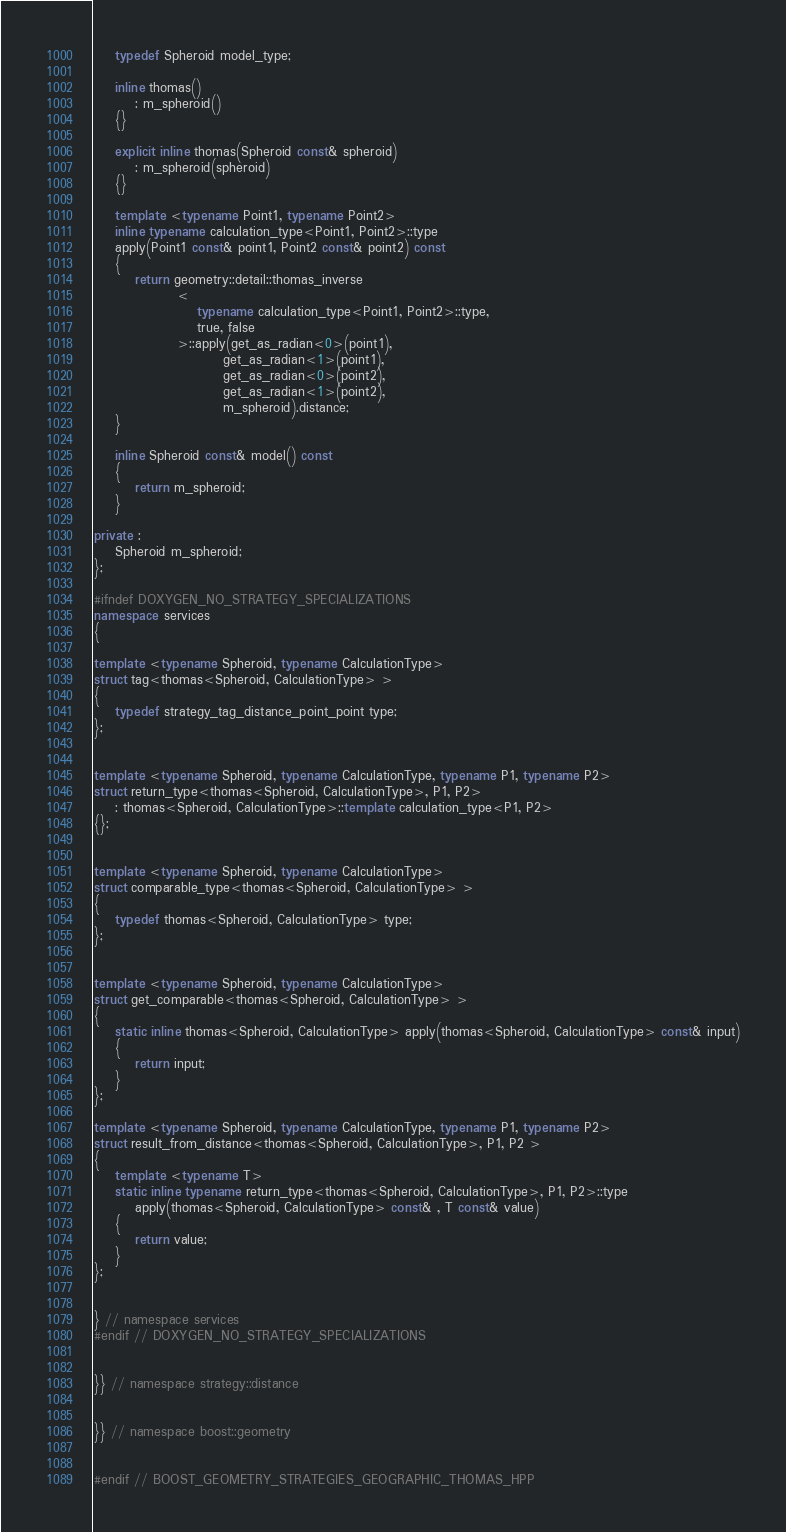<code> <loc_0><loc_0><loc_500><loc_500><_C++_>    typedef Spheroid model_type;

    inline thomas()
        : m_spheroid()
    {}

    explicit inline thomas(Spheroid const& spheroid)
        : m_spheroid(spheroid)
    {}

    template <typename Point1, typename Point2>
    inline typename calculation_type<Point1, Point2>::type
    apply(Point1 const& point1, Point2 const& point2) const
    {
        return geometry::detail::thomas_inverse
                <
                    typename calculation_type<Point1, Point2>::type,
                    true, false
                >::apply(get_as_radian<0>(point1),
                         get_as_radian<1>(point1),
                         get_as_radian<0>(point2),
                         get_as_radian<1>(point2),
                         m_spheroid).distance;
    }

    inline Spheroid const& model() const
    {
        return m_spheroid;
    }

private :
    Spheroid m_spheroid;
};

#ifndef DOXYGEN_NO_STRATEGY_SPECIALIZATIONS
namespace services
{

template <typename Spheroid, typename CalculationType>
struct tag<thomas<Spheroid, CalculationType> >
{
    typedef strategy_tag_distance_point_point type;
};


template <typename Spheroid, typename CalculationType, typename P1, typename P2>
struct return_type<thomas<Spheroid, CalculationType>, P1, P2>
    : thomas<Spheroid, CalculationType>::template calculation_type<P1, P2>
{};


template <typename Spheroid, typename CalculationType>
struct comparable_type<thomas<Spheroid, CalculationType> >
{
    typedef thomas<Spheroid, CalculationType> type;
};


template <typename Spheroid, typename CalculationType>
struct get_comparable<thomas<Spheroid, CalculationType> >
{
    static inline thomas<Spheroid, CalculationType> apply(thomas<Spheroid, CalculationType> const& input)
    {
        return input;
    }
};

template <typename Spheroid, typename CalculationType, typename P1, typename P2>
struct result_from_distance<thomas<Spheroid, CalculationType>, P1, P2 >
{
    template <typename T>
    static inline typename return_type<thomas<Spheroid, CalculationType>, P1, P2>::type
        apply(thomas<Spheroid, CalculationType> const& , T const& value)
    {
        return value;
    }
};


} // namespace services
#endif // DOXYGEN_NO_STRATEGY_SPECIALIZATIONS


}} // namespace strategy::distance


}} // namespace boost::geometry


#endif // BOOST_GEOMETRY_STRATEGIES_GEOGRAPHIC_THOMAS_HPP
</code> 